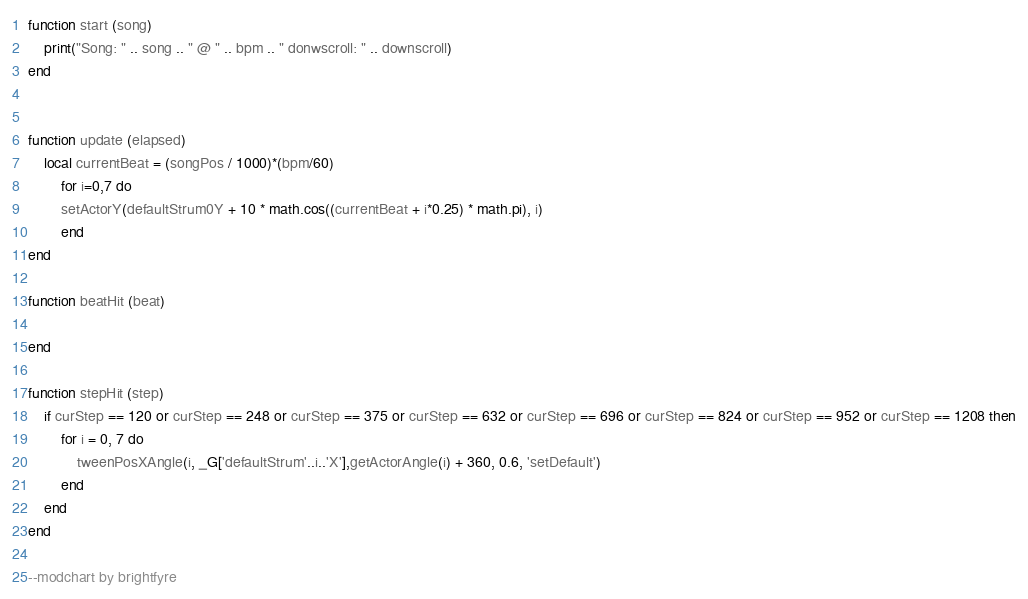<code> <loc_0><loc_0><loc_500><loc_500><_Lua_>function start (song)
	print("Song: " .. song .. " @ " .. bpm .. " donwscroll: " .. downscroll)
end


function update (elapsed)
    local currentBeat = (songPos / 1000)*(bpm/60)
        for i=0,7 do
        setActorY(defaultStrum0Y + 10 * math.cos((currentBeat + i*0.25) * math.pi), i)
        end
end

function beatHit (beat)

end

function stepHit (step)
    if curStep == 120 or curStep == 248 or curStep == 375 or curStep == 632 or curStep == 696 or curStep == 824 or curStep == 952 or curStep == 1208 then
        for i = 0, 7 do
            tweenPosXAngle(i, _G['defaultStrum'..i..'X'],getActorAngle(i) + 360, 0.6, 'setDefault')
        end
    end
end

--modchart by brightfyre</code> 